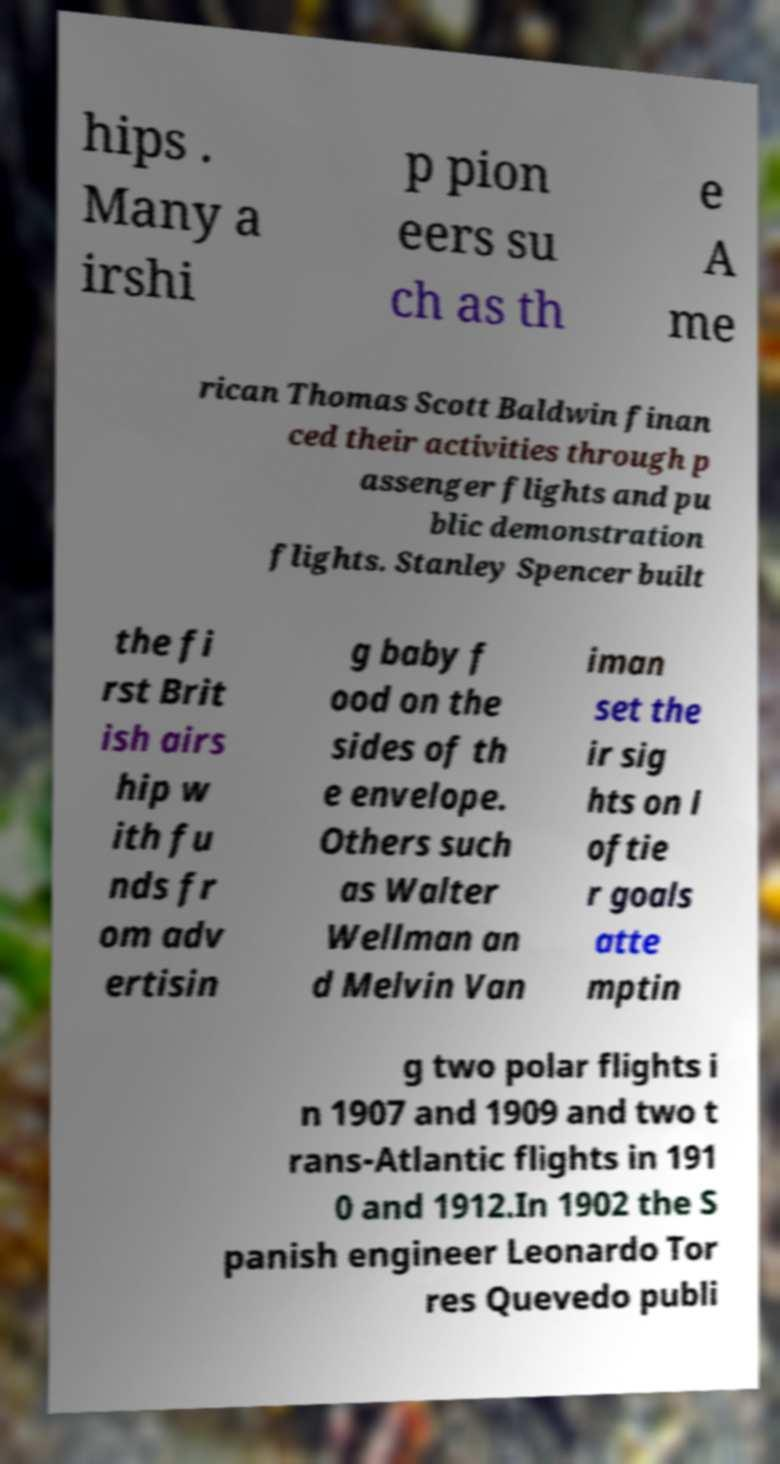There's text embedded in this image that I need extracted. Can you transcribe it verbatim? hips . Many a irshi p pion eers su ch as th e A me rican Thomas Scott Baldwin finan ced their activities through p assenger flights and pu blic demonstration flights. Stanley Spencer built the fi rst Brit ish airs hip w ith fu nds fr om adv ertisin g baby f ood on the sides of th e envelope. Others such as Walter Wellman an d Melvin Van iman set the ir sig hts on l oftie r goals atte mptin g two polar flights i n 1907 and 1909 and two t rans-Atlantic flights in 191 0 and 1912.In 1902 the S panish engineer Leonardo Tor res Quevedo publi 